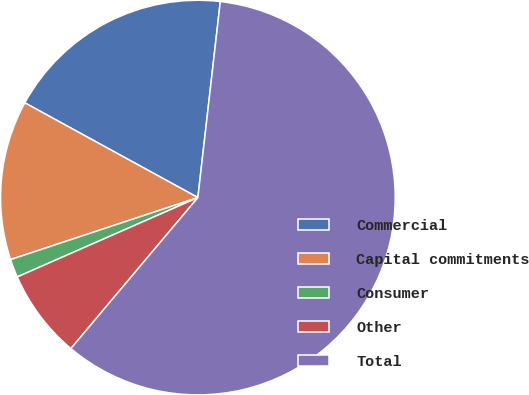Convert chart. <chart><loc_0><loc_0><loc_500><loc_500><pie_chart><fcel>Commercial<fcel>Capital commitments<fcel>Consumer<fcel>Other<fcel>Total<nl><fcel>18.84%<fcel>13.06%<fcel>1.5%<fcel>7.28%<fcel>59.31%<nl></chart> 